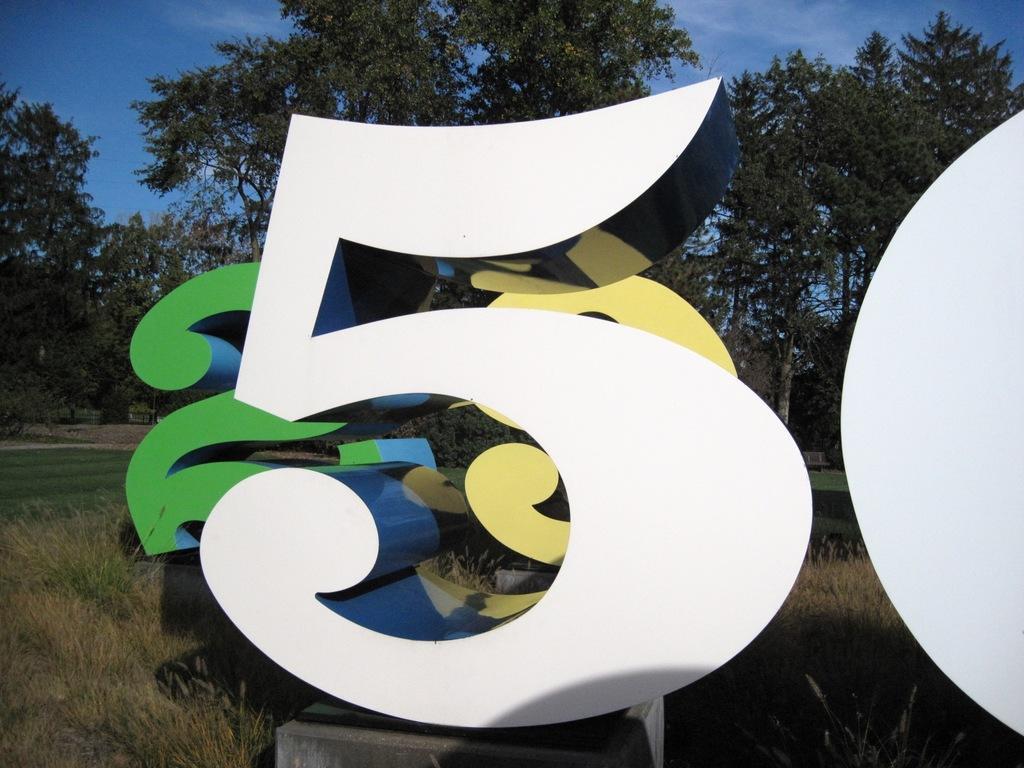Please provide a concise description of this image. In this image there is numberś on the surface, there are grass, there are plantś, there is the sky. 